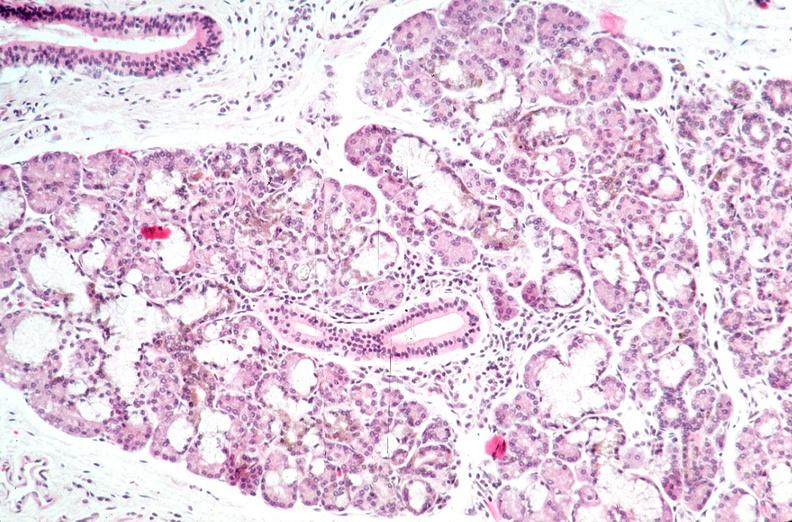what does this image show?
Answer the question using a single word or phrase. Pancreas 